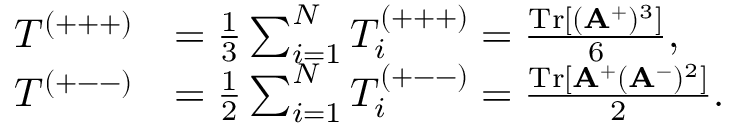<formula> <loc_0><loc_0><loc_500><loc_500>\begin{array} { r l } { T ^ { ( + + + ) } } & { = \frac { 1 } { 3 } \sum _ { i = 1 } ^ { N } T _ { i } ^ { ( + + + ) } = \frac { T r [ ( A ^ { + } ) ^ { 3 } ] } { 6 } , } \\ { T ^ { ( + - - ) } } & { = \frac { 1 } { 2 } \sum _ { i = 1 } ^ { N } T _ { i } ^ { ( + - - ) } = \frac { T r [ A ^ { + } ( A ^ { - } ) ^ { 2 } ] } { 2 } . } \end{array}</formula> 